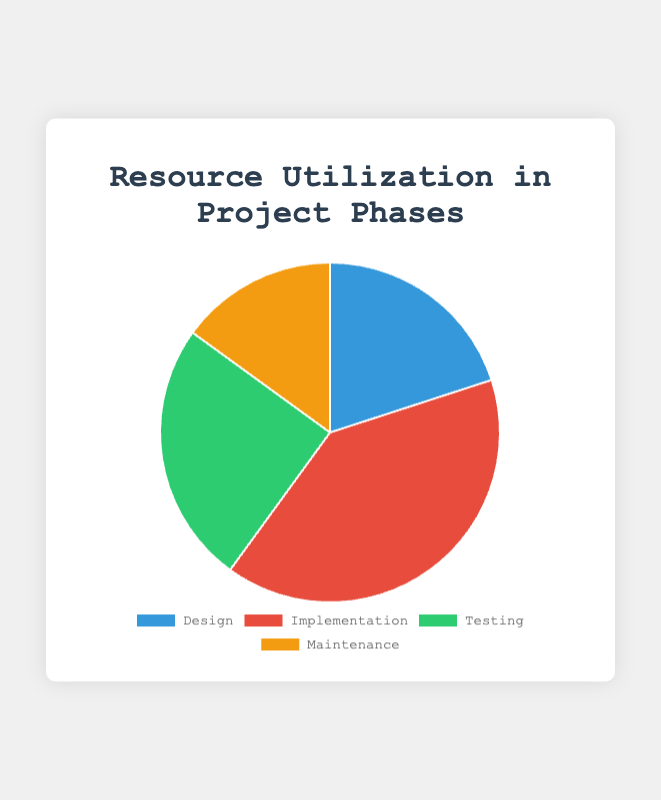What percentage of resources is utilized during the Maintenance phase? The chart shows a pie slice labeled "Maintenance," and the corresponding percentage is marked as 15%.
Answer: 15% Which project phase utilizes the most resources? By observing the pie chart, the largest slice corresponds to the "Implementation" phase, which has 40% resource utilization.
Answer: Implementation Which phase uses fewer resources, Design or Testing? By comparing the slices for "Design" and "Testing," we see that "Design" utilizes 20% of resources while "Testing" utilizes 25%. Therefore, Design uses fewer resources than Testing.
Answer: Design What is the combined resource utilization for the Design and Maintenance phases? The Design phase uses 20% and the Maintenance phase uses 15%. Adding these together, 20% + 15% = 35%.
Answer: 35% What is the difference in resource utilization between the Implementation and Testing phases? The Implementation phase uses 40% and the Testing phase uses 25%. The difference is 40% - 25% = 15%.
Answer: 15% Which phase is associated with the green slice in the pie chart? The chart legend shows that the green slice corresponds to the "Testing" phase.
Answer: Testing Are the resources utilized more during the Implementation phase than the total of the Design and Maintenance phases? The Implementation phase uses 40%, and the combined resource utilization for Design and Maintenance is 20% + 15% = 35%. Since 40% is greater than 35%, Implementation uses more resources.
Answer: Yes What is the average resource utilization across all project phases? The resource utilizations are 20%, 40%, 25%, and 15%. Adding them together gives 20 + 40 + 25 + 15 = 100. Dividing by the number of phases (4), the average is 100 / 4 = 25%.
Answer: 25% Is there any phase that uses exactly a quarter of the total resources? Checking the resource utilizations, the Testing phase uses 25%, which is exactly one-quarter of 100%.
Answer: Yes Which project phase represents the smallest utilization, and what color is its slice? The smallest utilization is for the Maintenance phase at 15%, and the legend shows that its slice is yellow.
Answer: Maintenance, yellow 